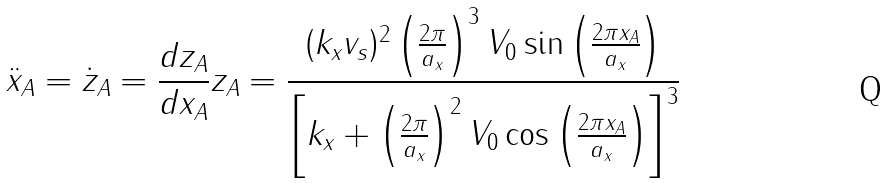<formula> <loc_0><loc_0><loc_500><loc_500>\ddot { x } _ { A } = \dot { z } _ { A } = \frac { d z _ { A } } { d x _ { A } } z _ { A } = \frac { ( k _ { x } v _ { s } ) ^ { 2 } \left ( \frac { 2 \pi } { a _ { x } } \right ) ^ { 3 } V _ { 0 } \sin \left ( \frac { 2 \pi x _ { A } } { a _ { x } } \right ) } { \left [ k _ { x } + \left ( \frac { 2 \pi } { a _ { x } } \right ) ^ { 2 } V _ { 0 } \cos \left ( \frac { 2 \pi x _ { A } } { a _ { x } } \right ) \right ] ^ { 3 } }</formula> 